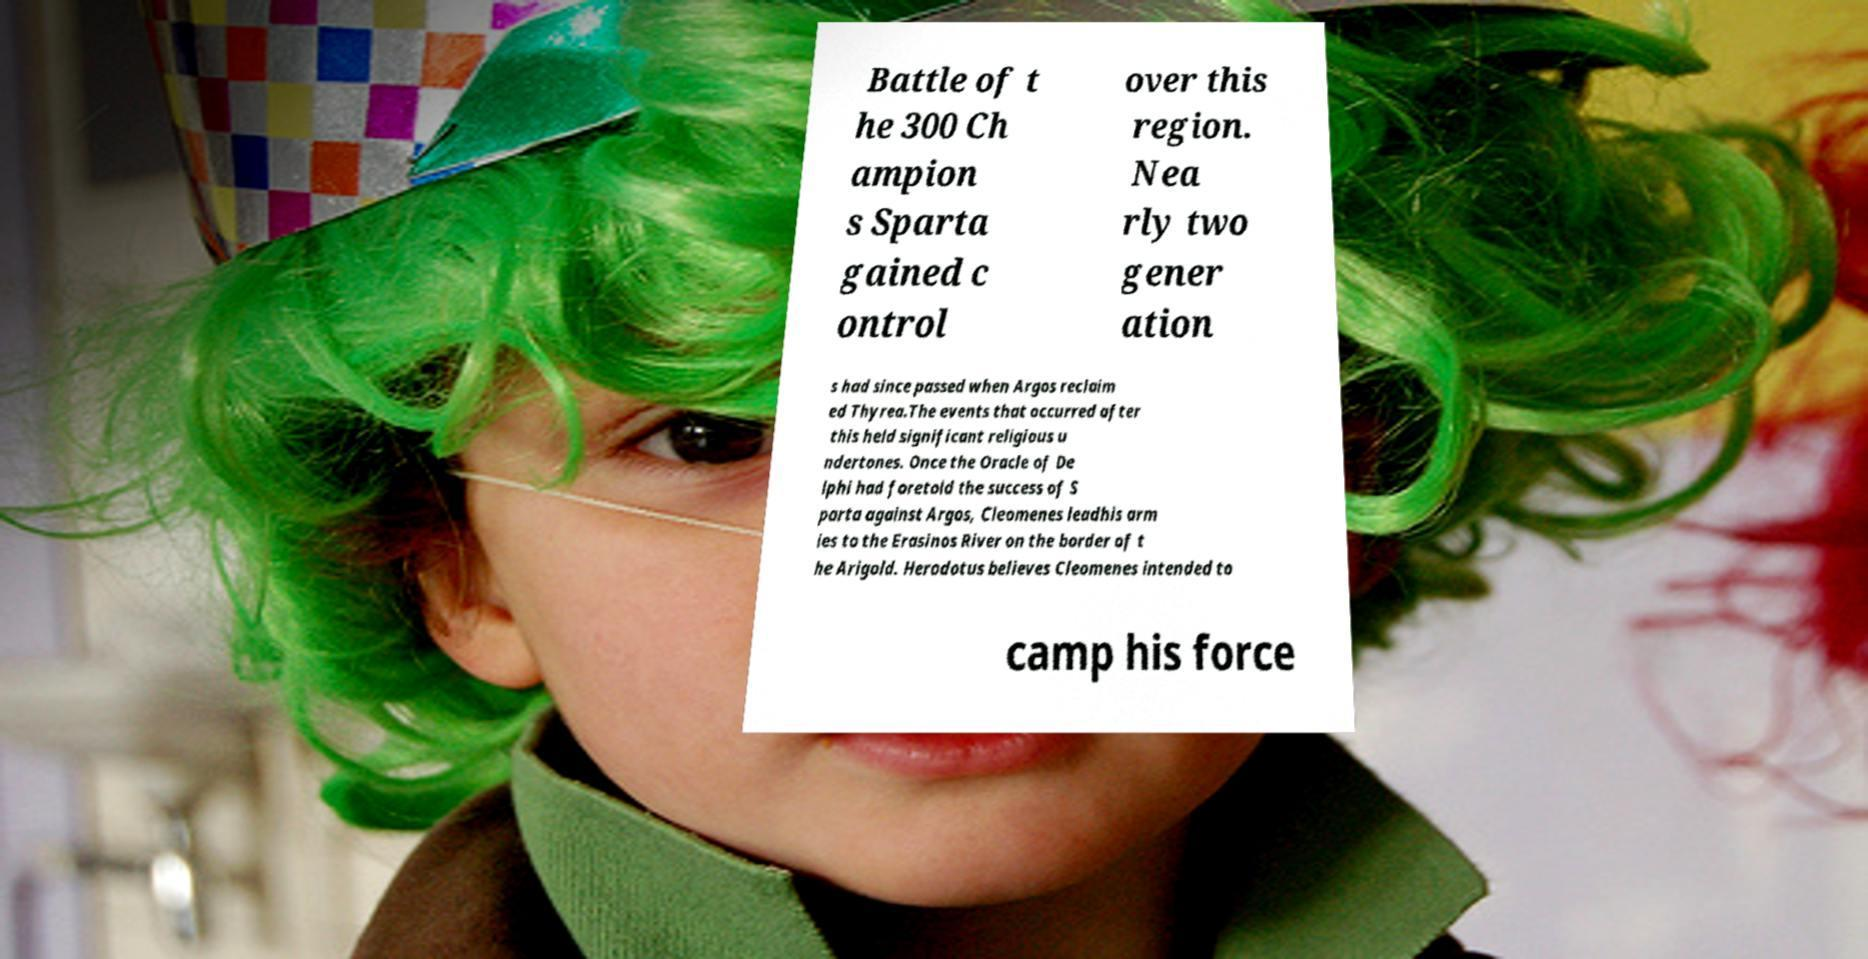For documentation purposes, I need the text within this image transcribed. Could you provide that? Battle of t he 300 Ch ampion s Sparta gained c ontrol over this region. Nea rly two gener ation s had since passed when Argos reclaim ed Thyrea.The events that occurred after this held significant religious u ndertones. Once the Oracle of De lphi had foretold the success of S parta against Argos, Cleomenes leadhis arm ies to the Erasinos River on the border of t he Arigold. Herodotus believes Cleomenes intended to camp his force 